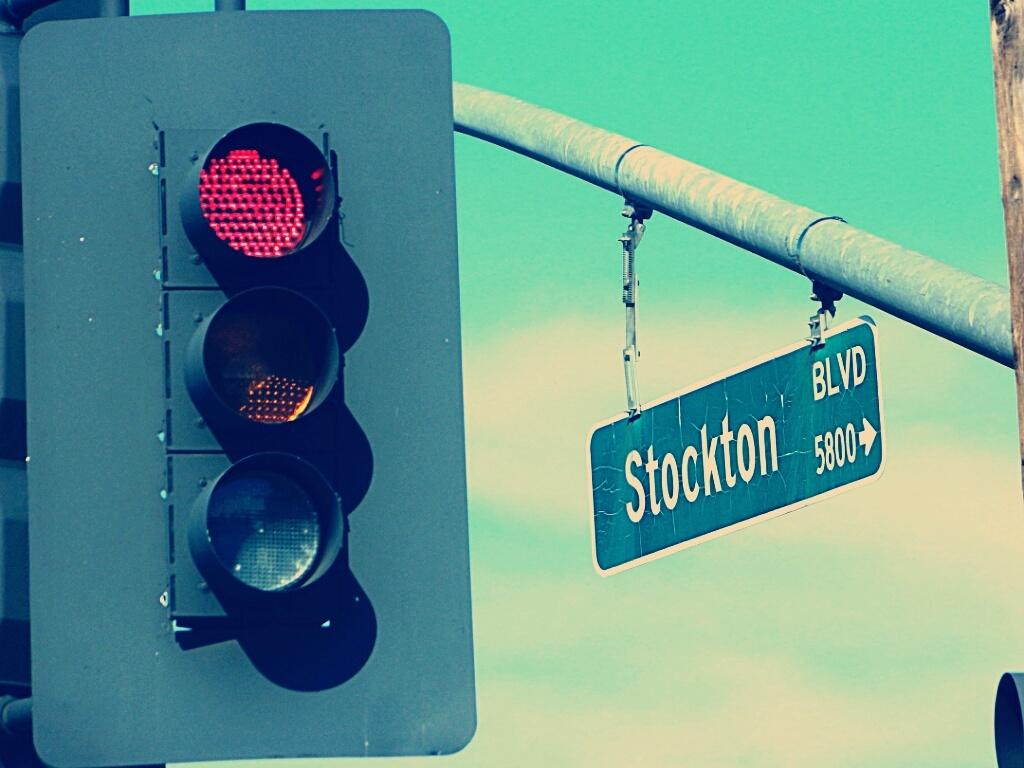What type of intersection is this?
Offer a terse response. Stockton blvd. 